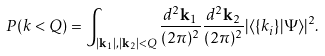<formula> <loc_0><loc_0><loc_500><loc_500>P ( k < Q ) = \int _ { | { \mathbf k } _ { 1 } | , | { \mathbf k } _ { 2 } | < Q } \frac { d ^ { 2 } { \mathbf k } _ { 1 } } { ( 2 \pi ) ^ { 2 } } \frac { d ^ { 2 } { \mathbf k } _ { 2 } } { ( 2 \pi ) ^ { 2 } } | \langle \{ { k } _ { i } \} | \Psi \rangle | ^ { 2 } .</formula> 